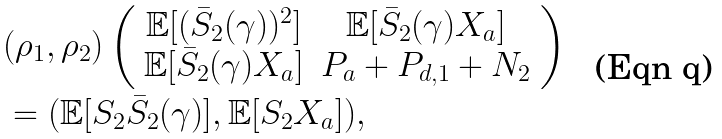<formula> <loc_0><loc_0><loc_500><loc_500>& ( \rho _ { 1 } , \rho _ { 2 } ) \left ( \begin{array} { c c } \mathbb { E } [ ( \bar { S } _ { 2 } ( \gamma ) ) ^ { 2 } ] & \mathbb { E } [ \bar { S } _ { 2 } ( \gamma ) X _ { a } ] \\ \mathbb { E } [ \bar { S } _ { 2 } ( \gamma ) X _ { a } ] & P _ { a } + P _ { d , 1 } + N _ { 2 } \\ \end{array} \right ) \\ & = ( \mathbb { E } [ S _ { 2 } \bar { S } _ { 2 } ( \gamma ) ] , \mathbb { E } [ S _ { 2 } X _ { a } ] ) ,</formula> 